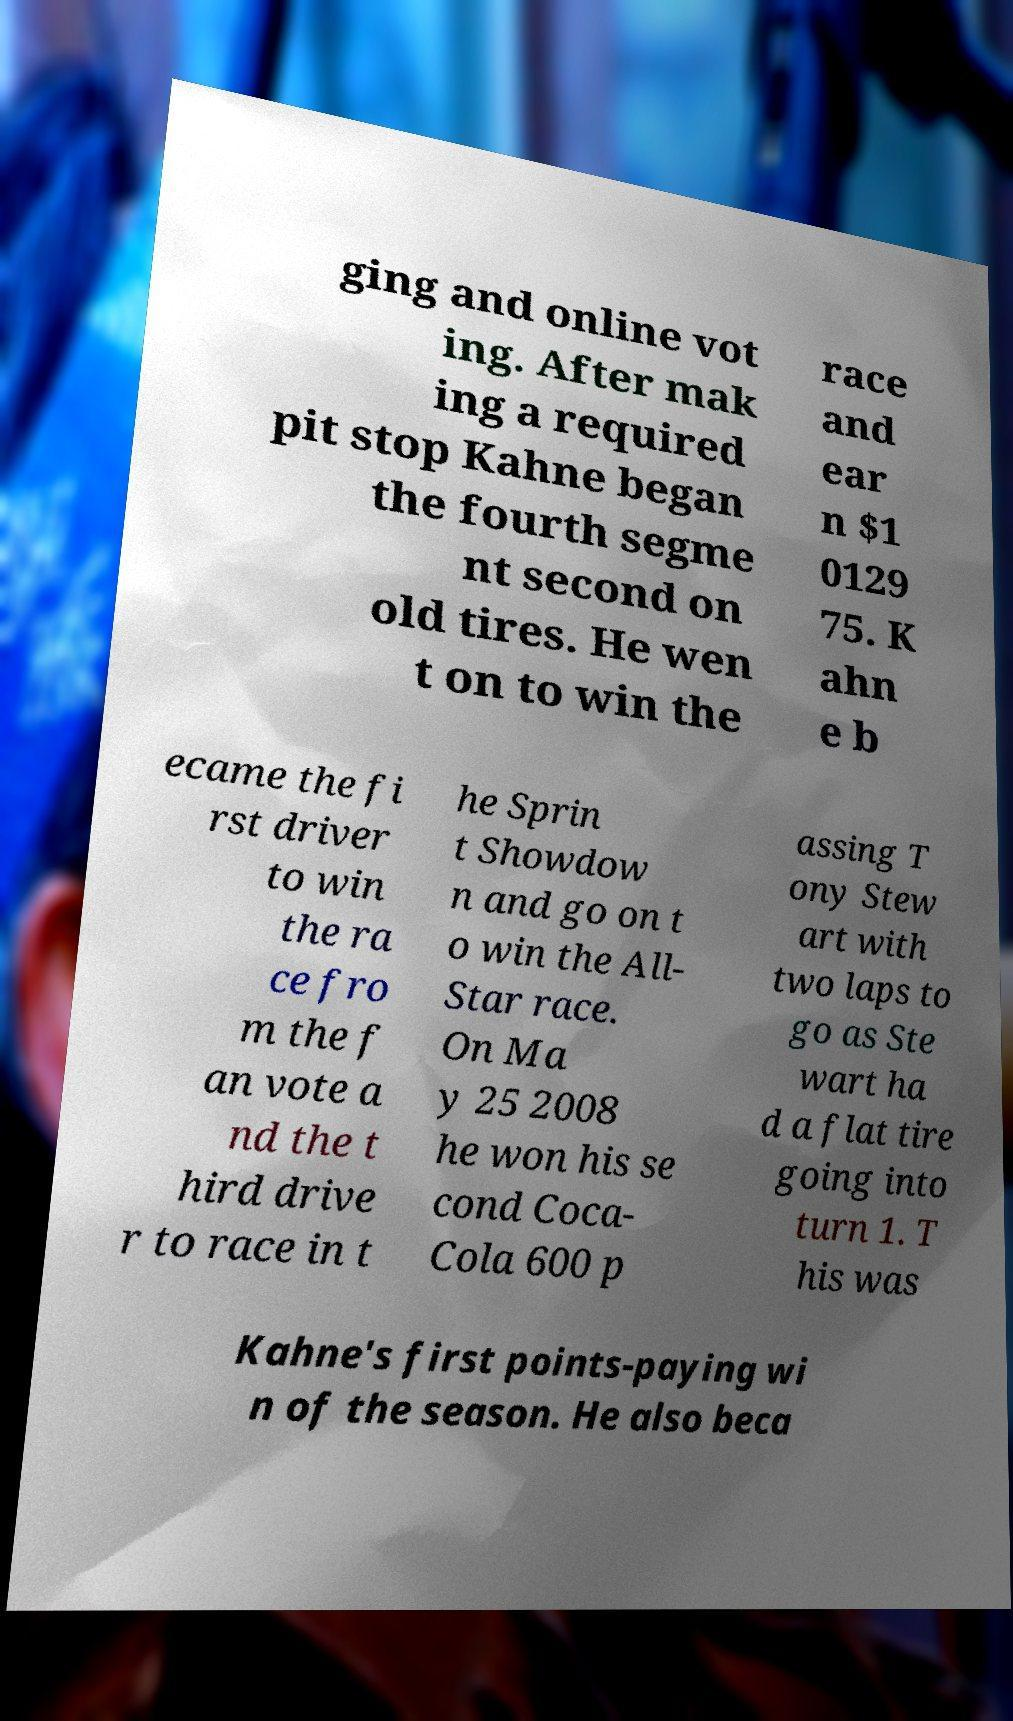There's text embedded in this image that I need extracted. Can you transcribe it verbatim? ging and online vot ing. After mak ing a required pit stop Kahne began the fourth segme nt second on old tires. He wen t on to win the race and ear n $1 0129 75. K ahn e b ecame the fi rst driver to win the ra ce fro m the f an vote a nd the t hird drive r to race in t he Sprin t Showdow n and go on t o win the All- Star race. On Ma y 25 2008 he won his se cond Coca- Cola 600 p assing T ony Stew art with two laps to go as Ste wart ha d a flat tire going into turn 1. T his was Kahne's first points-paying wi n of the season. He also beca 